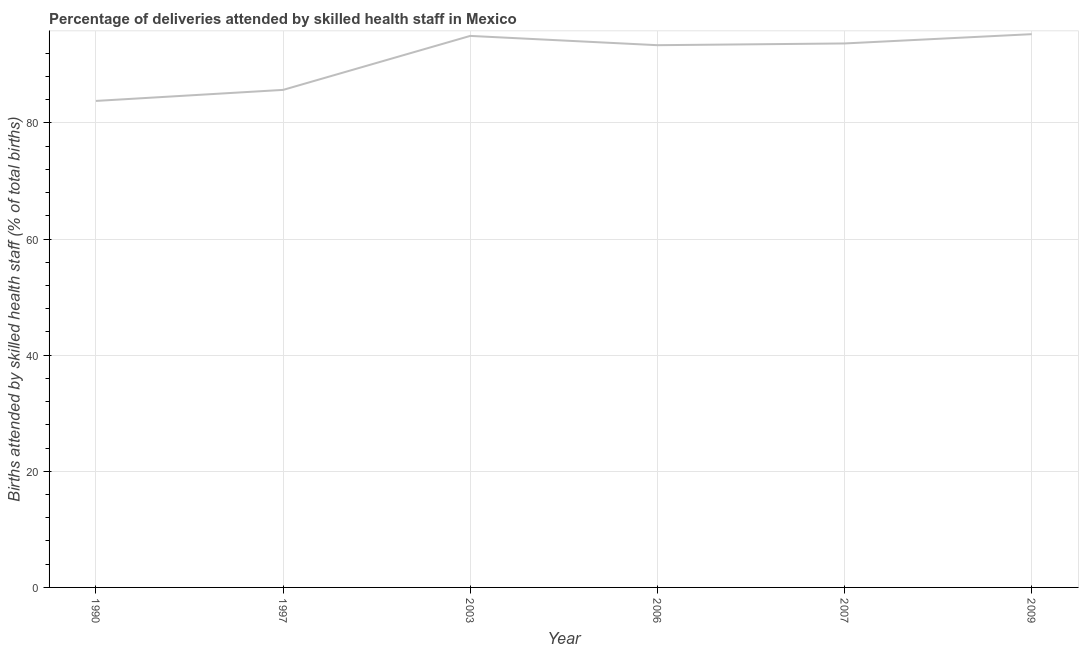What is the number of births attended by skilled health staff in 1997?
Give a very brief answer. 85.7. Across all years, what is the maximum number of births attended by skilled health staff?
Offer a very short reply. 95.3. Across all years, what is the minimum number of births attended by skilled health staff?
Provide a succinct answer. 83.8. What is the sum of the number of births attended by skilled health staff?
Provide a succinct answer. 546.9. What is the difference between the number of births attended by skilled health staff in 2007 and 2009?
Provide a short and direct response. -1.6. What is the average number of births attended by skilled health staff per year?
Ensure brevity in your answer.  91.15. What is the median number of births attended by skilled health staff?
Keep it short and to the point. 93.55. In how many years, is the number of births attended by skilled health staff greater than 32 %?
Give a very brief answer. 6. Do a majority of the years between 1990 and 2006 (inclusive) have number of births attended by skilled health staff greater than 72 %?
Provide a short and direct response. Yes. What is the ratio of the number of births attended by skilled health staff in 1997 to that in 2003?
Give a very brief answer. 0.9. Is the number of births attended by skilled health staff in 2003 less than that in 2007?
Make the answer very short. No. Is the difference between the number of births attended by skilled health staff in 2003 and 2007 greater than the difference between any two years?
Ensure brevity in your answer.  No. What is the difference between the highest and the second highest number of births attended by skilled health staff?
Make the answer very short. 0.3. Is the sum of the number of births attended by skilled health staff in 1997 and 2007 greater than the maximum number of births attended by skilled health staff across all years?
Keep it short and to the point. Yes. Does the number of births attended by skilled health staff monotonically increase over the years?
Give a very brief answer. No. How many lines are there?
Offer a terse response. 1. How many years are there in the graph?
Give a very brief answer. 6. What is the difference between two consecutive major ticks on the Y-axis?
Ensure brevity in your answer.  20. Are the values on the major ticks of Y-axis written in scientific E-notation?
Give a very brief answer. No. What is the title of the graph?
Ensure brevity in your answer.  Percentage of deliveries attended by skilled health staff in Mexico. What is the label or title of the Y-axis?
Your answer should be very brief. Births attended by skilled health staff (% of total births). What is the Births attended by skilled health staff (% of total births) in 1990?
Provide a short and direct response. 83.8. What is the Births attended by skilled health staff (% of total births) of 1997?
Provide a succinct answer. 85.7. What is the Births attended by skilled health staff (% of total births) in 2003?
Provide a short and direct response. 95. What is the Births attended by skilled health staff (% of total births) of 2006?
Ensure brevity in your answer.  93.4. What is the Births attended by skilled health staff (% of total births) in 2007?
Your response must be concise. 93.7. What is the Births attended by skilled health staff (% of total births) of 2009?
Provide a short and direct response. 95.3. What is the difference between the Births attended by skilled health staff (% of total births) in 1990 and 1997?
Give a very brief answer. -1.9. What is the difference between the Births attended by skilled health staff (% of total births) in 1990 and 2006?
Your answer should be very brief. -9.6. What is the difference between the Births attended by skilled health staff (% of total births) in 1990 and 2007?
Give a very brief answer. -9.9. What is the difference between the Births attended by skilled health staff (% of total births) in 1997 and 2007?
Keep it short and to the point. -8. What is the difference between the Births attended by skilled health staff (% of total births) in 1997 and 2009?
Ensure brevity in your answer.  -9.6. What is the difference between the Births attended by skilled health staff (% of total births) in 2003 and 2006?
Keep it short and to the point. 1.6. What is the difference between the Births attended by skilled health staff (% of total births) in 2003 and 2007?
Offer a terse response. 1.3. What is the difference between the Births attended by skilled health staff (% of total births) in 2003 and 2009?
Your answer should be very brief. -0.3. What is the difference between the Births attended by skilled health staff (% of total births) in 2006 and 2007?
Offer a very short reply. -0.3. What is the difference between the Births attended by skilled health staff (% of total births) in 2007 and 2009?
Your answer should be very brief. -1.6. What is the ratio of the Births attended by skilled health staff (% of total births) in 1990 to that in 1997?
Offer a very short reply. 0.98. What is the ratio of the Births attended by skilled health staff (% of total births) in 1990 to that in 2003?
Your response must be concise. 0.88. What is the ratio of the Births attended by skilled health staff (% of total births) in 1990 to that in 2006?
Your answer should be compact. 0.9. What is the ratio of the Births attended by skilled health staff (% of total births) in 1990 to that in 2007?
Provide a succinct answer. 0.89. What is the ratio of the Births attended by skilled health staff (% of total births) in 1990 to that in 2009?
Offer a terse response. 0.88. What is the ratio of the Births attended by skilled health staff (% of total births) in 1997 to that in 2003?
Give a very brief answer. 0.9. What is the ratio of the Births attended by skilled health staff (% of total births) in 1997 to that in 2006?
Offer a terse response. 0.92. What is the ratio of the Births attended by skilled health staff (% of total births) in 1997 to that in 2007?
Give a very brief answer. 0.92. What is the ratio of the Births attended by skilled health staff (% of total births) in 1997 to that in 2009?
Ensure brevity in your answer.  0.9. What is the ratio of the Births attended by skilled health staff (% of total births) in 2003 to that in 2009?
Give a very brief answer. 1. What is the ratio of the Births attended by skilled health staff (% of total births) in 2006 to that in 2007?
Your response must be concise. 1. What is the ratio of the Births attended by skilled health staff (% of total births) in 2007 to that in 2009?
Offer a terse response. 0.98. 